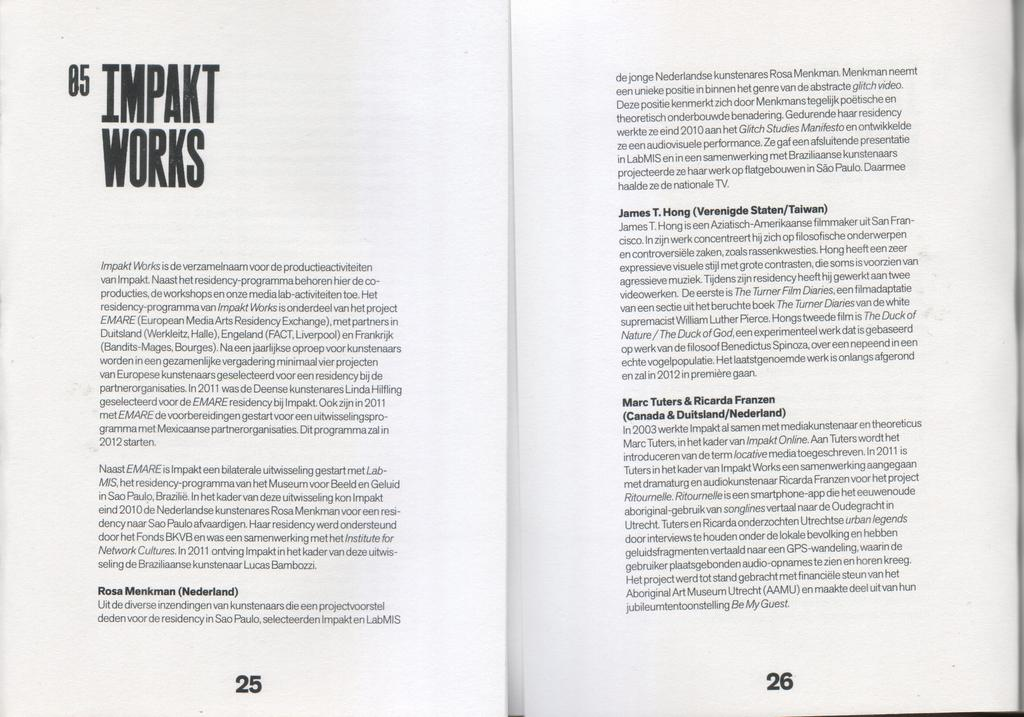Provide a one-sentence caption for the provided image. A book is open to page 25 and 26 with the title Impakt Works. 